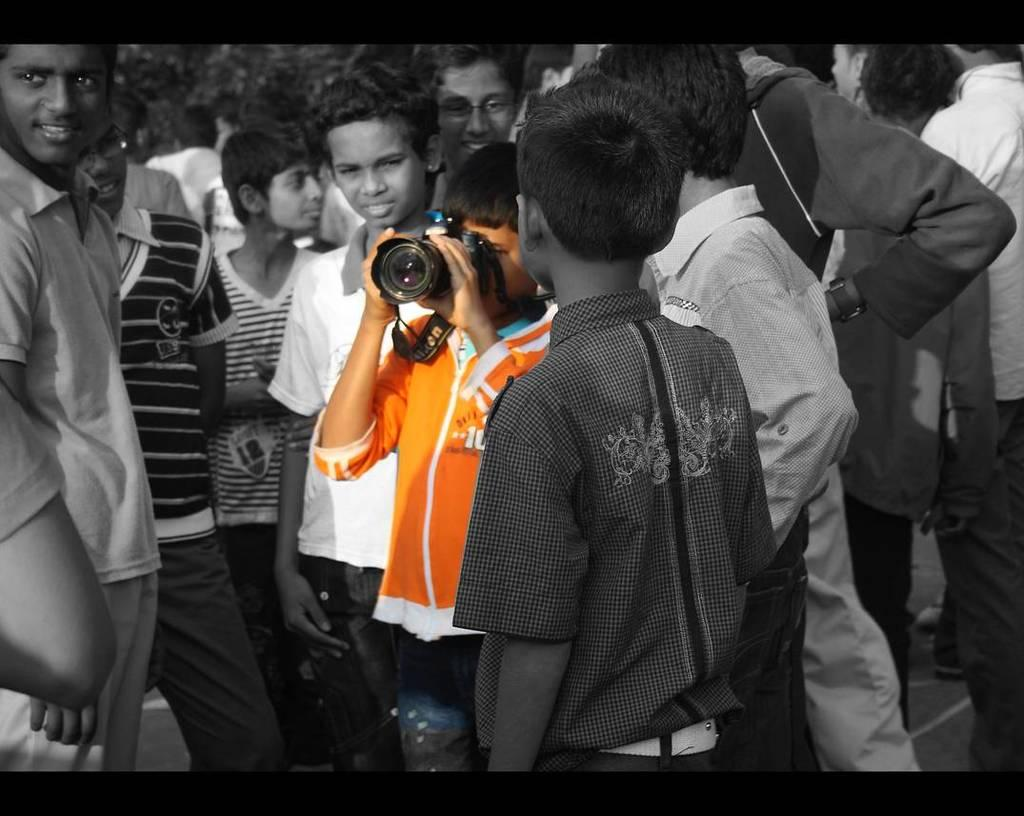How many people are in the image? There is a group of people in the image. What is the boy in the image doing? The boy is holding a camera in his hand and taking a picture. What can be seen in the background of the image? There are trees in the background of the image. What type of vein is visible in the image? There is no vein visible in the image. How many teeth can be seen in the boy's smile in the image? The image does not show the boy's teeth or smile, so it cannot be determined from the image. 